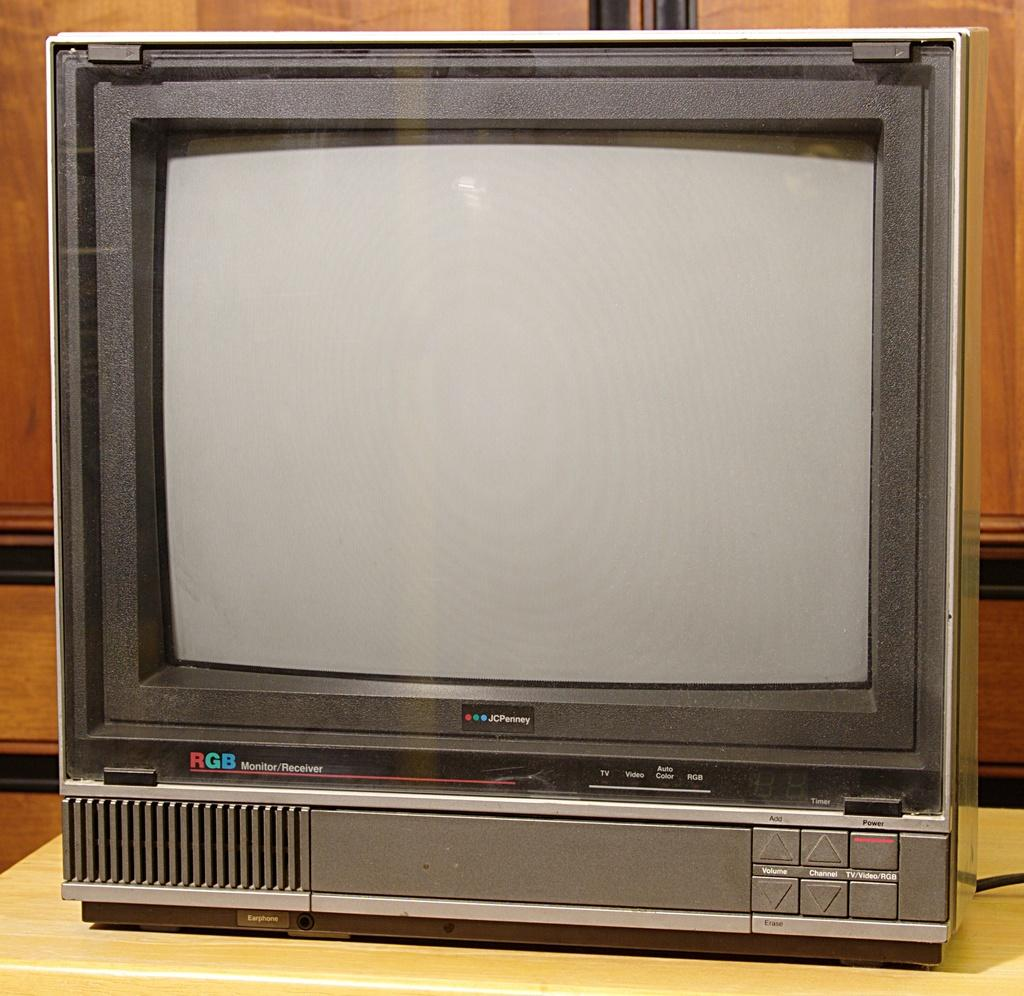<image>
Relay a brief, clear account of the picture shown. The old RGB Monitor/Receiver was from JC Penney. 